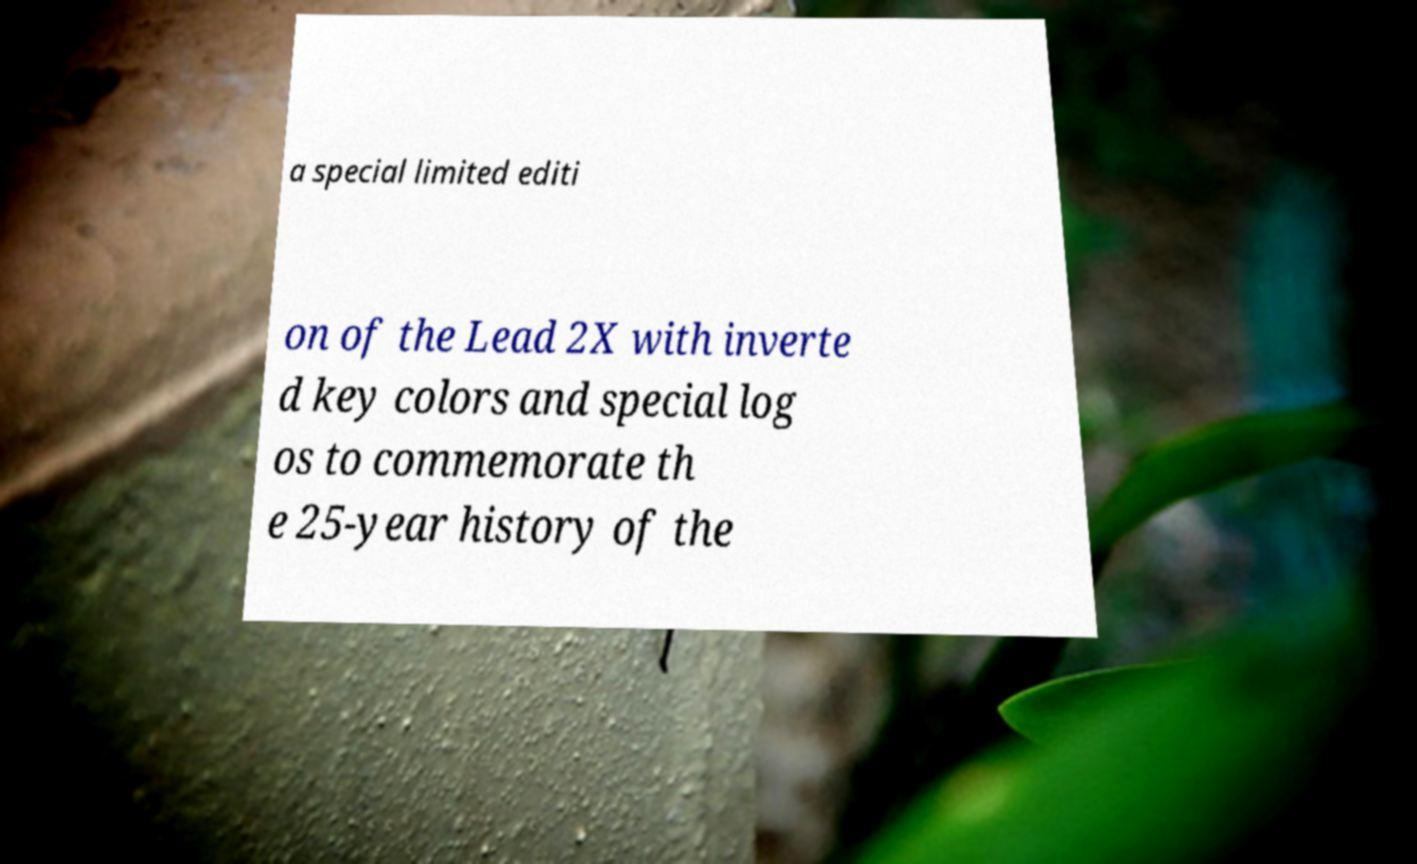I need the written content from this picture converted into text. Can you do that? a special limited editi on of the Lead 2X with inverte d key colors and special log os to commemorate th e 25-year history of the 